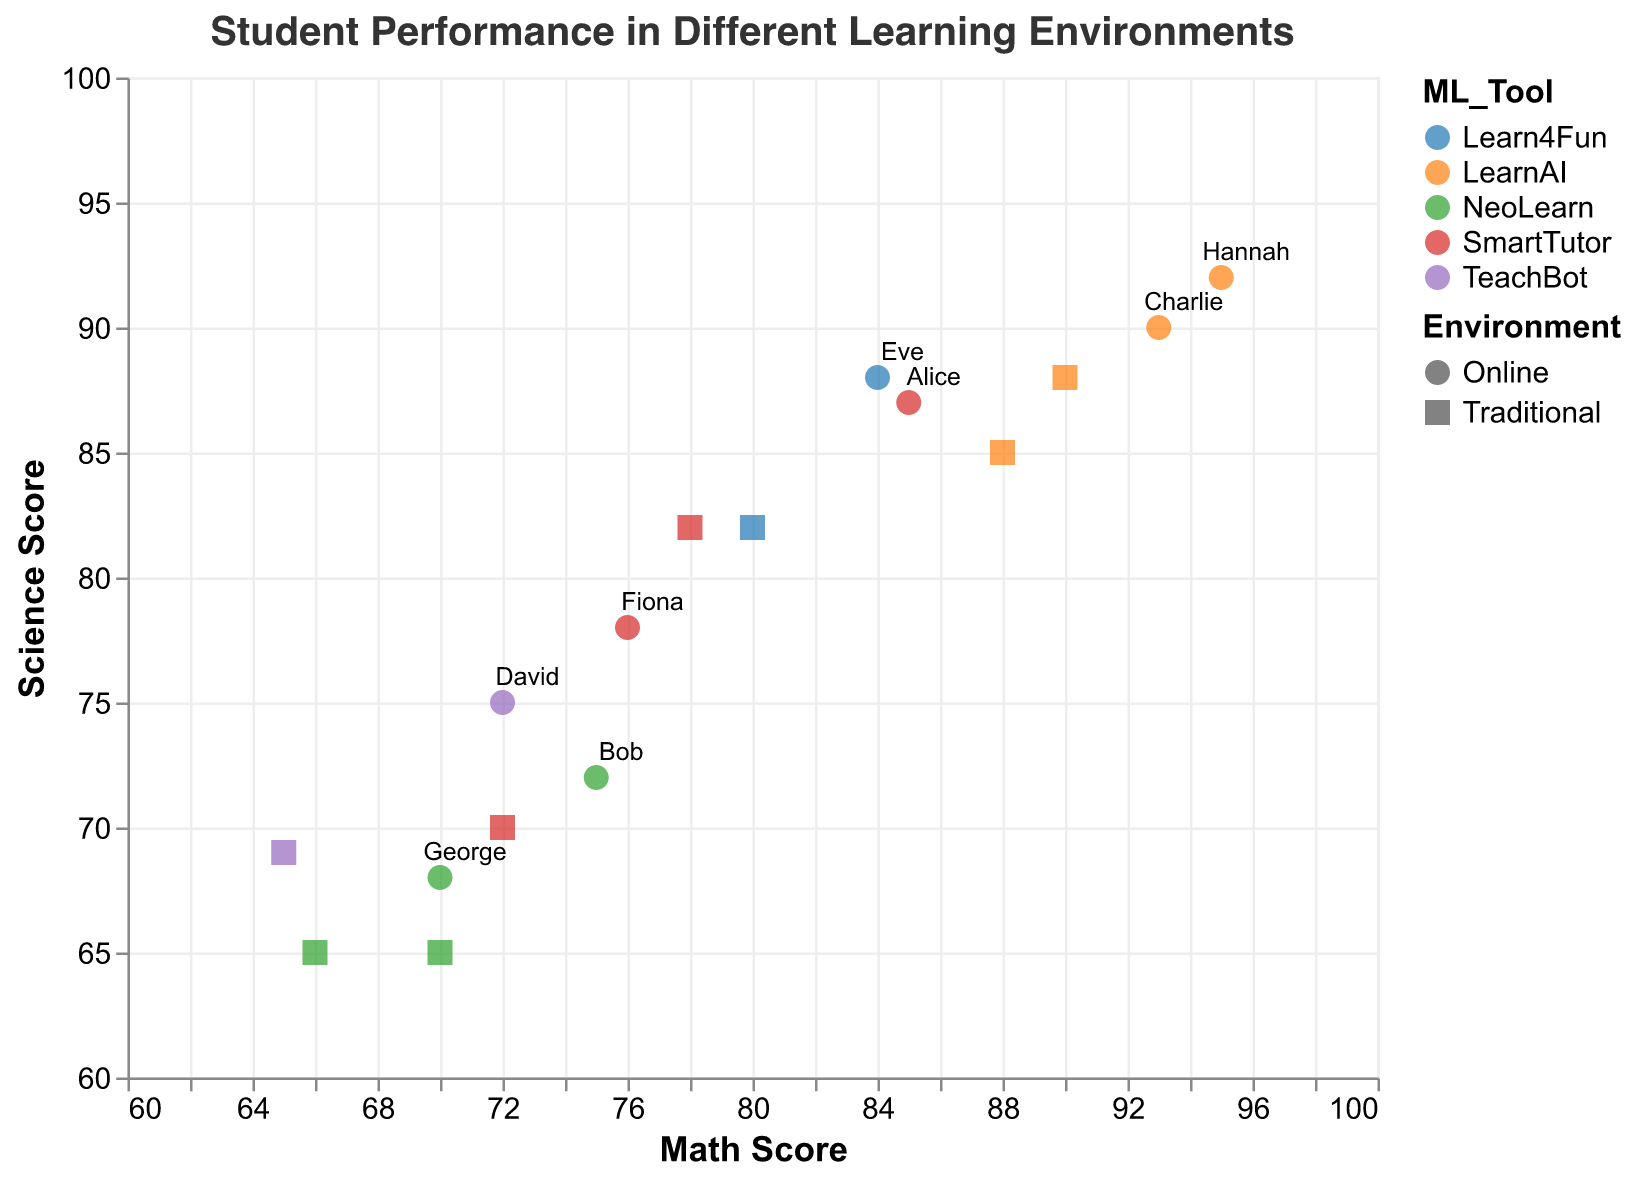What is the title of the plot? The title of the plot is displayed at the top in a readable font. Simply read it to find the answer.
Answer: Student Performance in Different Learning Environments What is the range of Math Scores in the plot? The x-axis represents the Math Scores, and it ranges from 60 to 100. This can be identified by examining the axis labels.
Answer: 60 to 100 Which student has the highest science score in a traditional environment? Look for the point that represents the highest Science Score among points with a shape indicating a traditional environment. The tooltip or text label for this point will reveal the student's name.
Answer: Hannah Do students generally perform better in the online or traditional environment for math scores? Compare the positions of points corresponding to each environment (indicated by different shapes) along the x-axis. Evaluate if the online points tend to be further right (higher Math Scores) than the traditional points.
Answer: Online What's the average Math Score of students using SmartTutor in the traditional environment? Identify students using SmartTutor in a traditional environment (Alice and Fiona). Add their Math Scores (78 + 72 = 150) and divide by the number of students (2) to get the average.
Answer: 75 Compare Charlie's Math Scores in traditional vs. online environments. Find Charlie's data points (point labeled "Charlie"). Note his Math Scores in traditional (88) and online (93) environments and compare them.
Answer: Traditional: 88, Online: 93 Which ML tool is associated with the highest combined Math and Science Score in an online environment? For each ML tool, find the combined Math and Science Scores of the online points. The student with the highest combined score (Math + Science) will reveal the ML tool used.
Answer: LearnAI (Charlie, combined score: 93 + 90 = 183) Did any student score lower in Math but higher in Science in an online environment compared to a traditional environment? Compare each student's Math and Science Scores between the two environments. Look for cases where the Math Score decreased, but the Science Score increased in the online environment.
Answer: No How many students use the NeoLearn tool, and what are their ranges of performance in a traditional environment? Count the unique students using NeoLearn and examine their data points in traditional environments for their Math, Science, and Reading Scores ranges.
Answer: 2 students (Bob and George), Math: 66-70, Science: 65, Reading: 67-72 